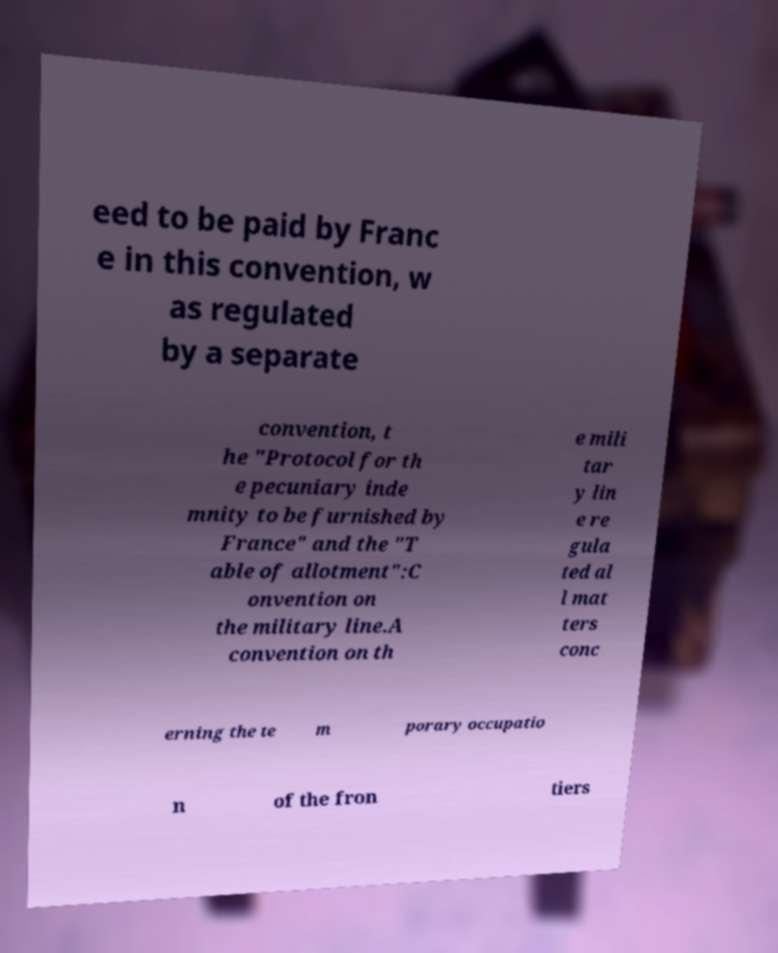Can you read and provide the text displayed in the image?This photo seems to have some interesting text. Can you extract and type it out for me? eed to be paid by Franc e in this convention, w as regulated by a separate convention, t he "Protocol for th e pecuniary inde mnity to be furnished by France" and the "T able of allotment":C onvention on the military line.A convention on th e mili tar y lin e re gula ted al l mat ters conc erning the te m porary occupatio n of the fron tiers 